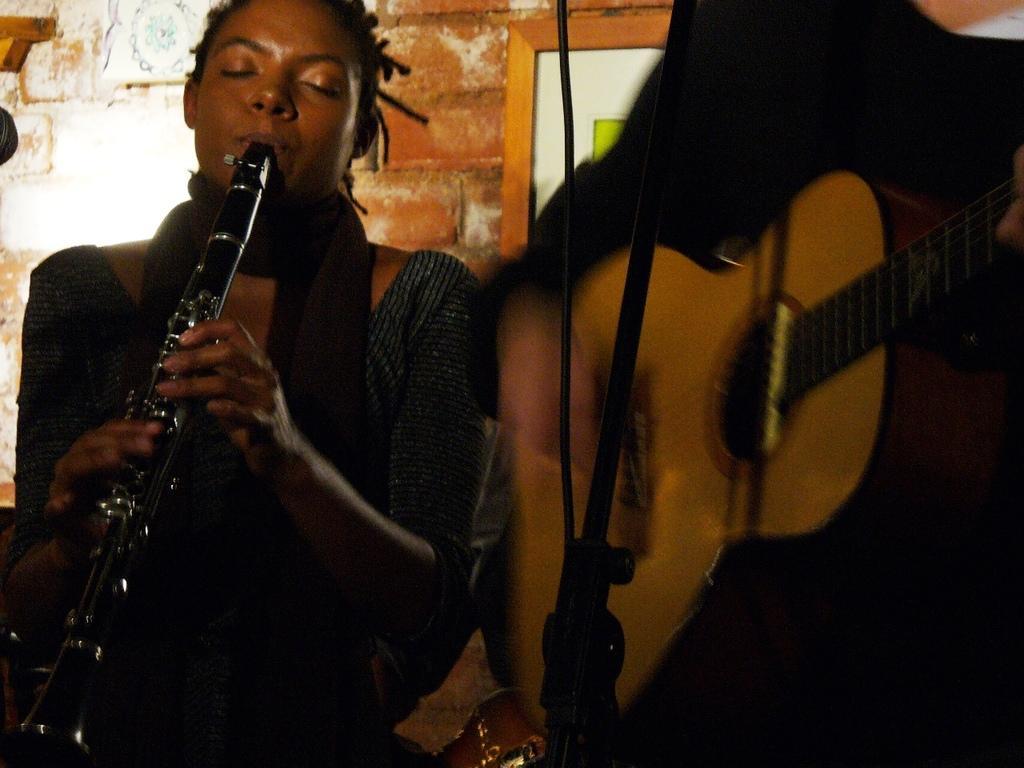Describe this image in one or two sentences. In this image, we can see few peoples are playing a musical instrument. At the back side, we can see brick wall and photo frame. 